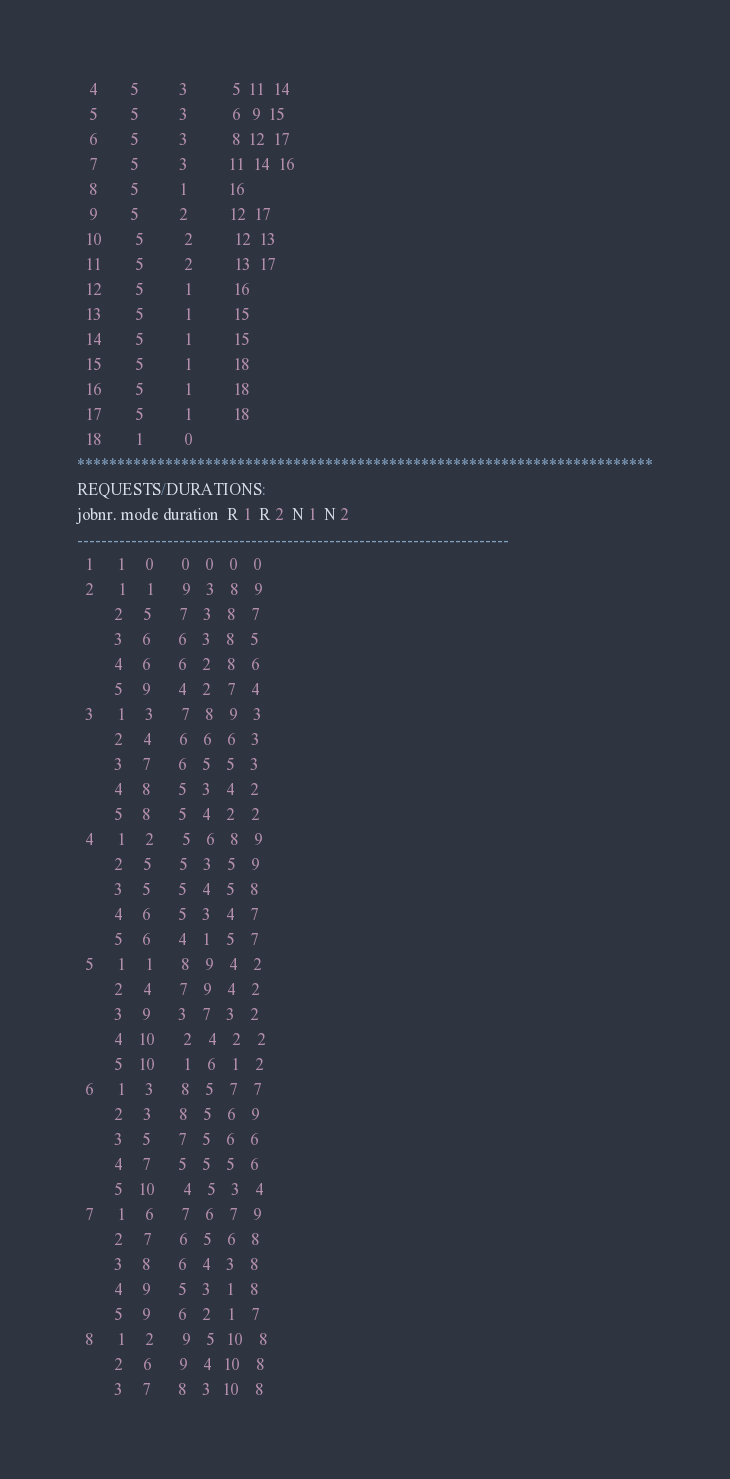Convert code to text. <code><loc_0><loc_0><loc_500><loc_500><_ObjectiveC_>   4        5          3           5  11  14
   5        5          3           6   9  15
   6        5          3           8  12  17
   7        5          3          11  14  16
   8        5          1          16
   9        5          2          12  17
  10        5          2          12  13
  11        5          2          13  17
  12        5          1          16
  13        5          1          15
  14        5          1          15
  15        5          1          18
  16        5          1          18
  17        5          1          18
  18        1          0        
************************************************************************
REQUESTS/DURATIONS:
jobnr. mode duration  R 1  R 2  N 1  N 2
------------------------------------------------------------------------
  1      1     0       0    0    0    0
  2      1     1       9    3    8    9
         2     5       7    3    8    7
         3     6       6    3    8    5
         4     6       6    2    8    6
         5     9       4    2    7    4
  3      1     3       7    8    9    3
         2     4       6    6    6    3
         3     7       6    5    5    3
         4     8       5    3    4    2
         5     8       5    4    2    2
  4      1     2       5    6    8    9
         2     5       5    3    5    9
         3     5       5    4    5    8
         4     6       5    3    4    7
         5     6       4    1    5    7
  5      1     1       8    9    4    2
         2     4       7    9    4    2
         3     9       3    7    3    2
         4    10       2    4    2    2
         5    10       1    6    1    2
  6      1     3       8    5    7    7
         2     3       8    5    6    9
         3     5       7    5    6    6
         4     7       5    5    5    6
         5    10       4    5    3    4
  7      1     6       7    6    7    9
         2     7       6    5    6    8
         3     8       6    4    3    8
         4     9       5    3    1    8
         5     9       6    2    1    7
  8      1     2       9    5   10    8
         2     6       9    4   10    8
         3     7       8    3   10    8</code> 